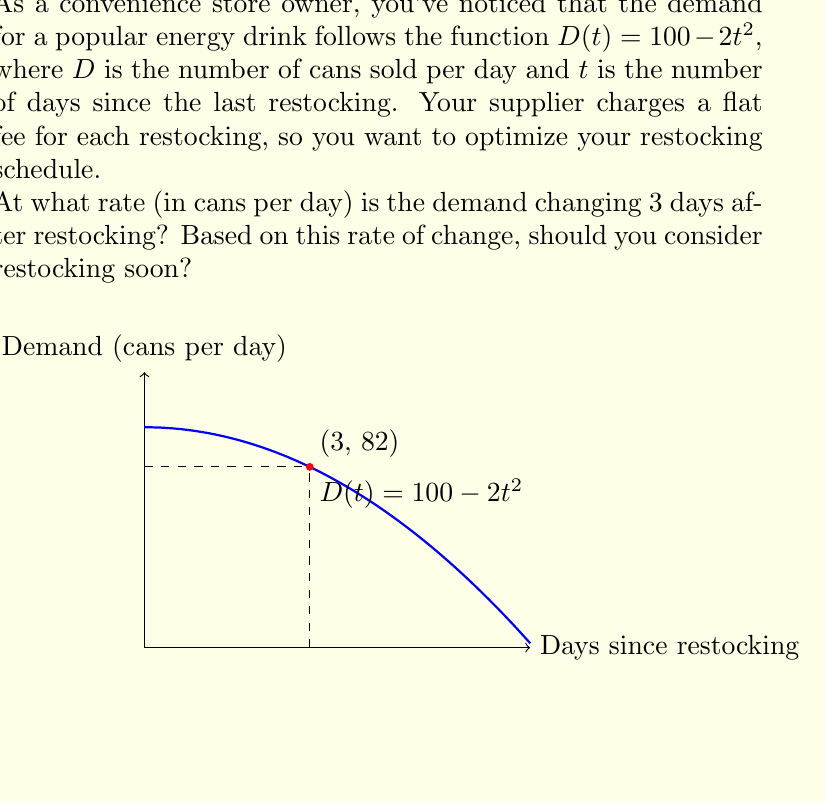Provide a solution to this math problem. To solve this problem, we need to find the rate of change of the demand function at $t = 3$ days. This is equivalent to finding the derivative of $D(t)$ and evaluating it at $t = 3$.

Step 1: Find the derivative of $D(t)$.
$D(t) = 100 - 2t^2$
$D'(t) = -4t$ (using the power rule)

Step 2: Evaluate $D'(t)$ at $t = 3$.
$D'(3) = -4(3) = -12$

The negative sign indicates that the demand is decreasing.

Step 3: Interpret the result.
The rate of change is -12 cans per day, meaning the demand is decreasing by 12 cans each day at the 3-day mark after restocking.

Step 4: Consider restocking decision.
Given that the demand is decreasing at a significant rate (12 cans per day), and the current demand at day 3 is $D(3) = 100 - 2(3)^2 = 82$ cans, it would be advisable to consider restocking soon. The rapid decrease in demand suggests that waiting much longer could result in potential lost sales due to insufficient stock.
Answer: -12 cans/day; Yes, consider restocking soon. 